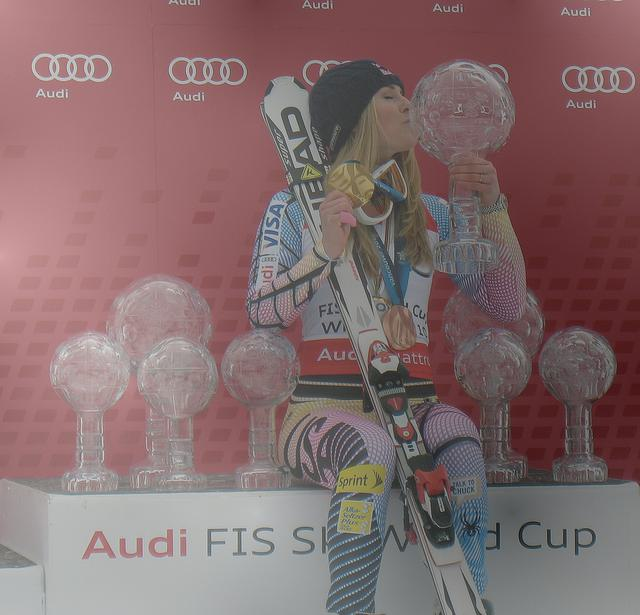Can you describe the significance of the trophies seen in the background? The trophies in the background, which are large and ornate crystal globes, signify major achievements within competitive skiing. They are typically awarded to the overall winners in different categories or disciplines as part of the FIS World Cup series. 